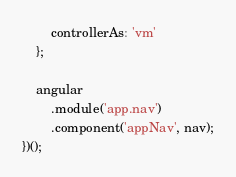<code> <loc_0><loc_0><loc_500><loc_500><_JavaScript_>		controllerAs: 'vm'
	};

	angular
		.module('app.nav')
		.component('appNav', nav);
})();
</code> 